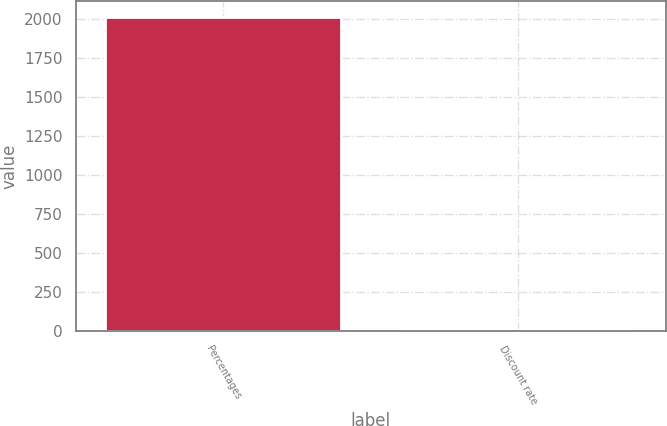<chart> <loc_0><loc_0><loc_500><loc_500><bar_chart><fcel>Percentages<fcel>Discount rate<nl><fcel>2011<fcel>5.35<nl></chart> 